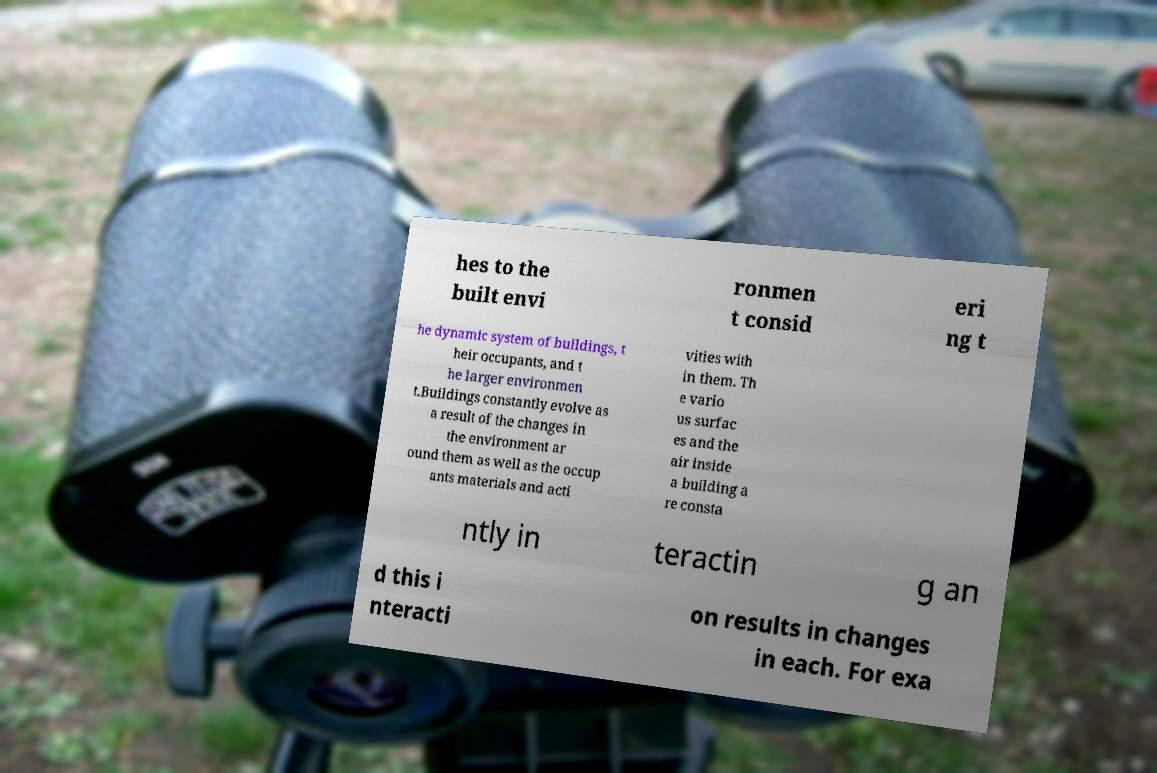For documentation purposes, I need the text within this image transcribed. Could you provide that? hes to the built envi ronmen t consid eri ng t he dynamic system of buildings, t heir occupants, and t he larger environmen t.Buildings constantly evolve as a result of the changes in the environment ar ound them as well as the occup ants materials and acti vities with in them. Th e vario us surfac es and the air inside a building a re consta ntly in teractin g an d this i nteracti on results in changes in each. For exa 